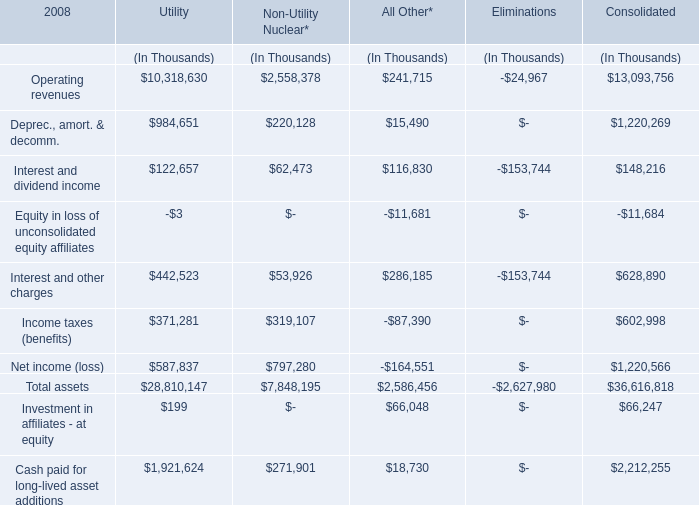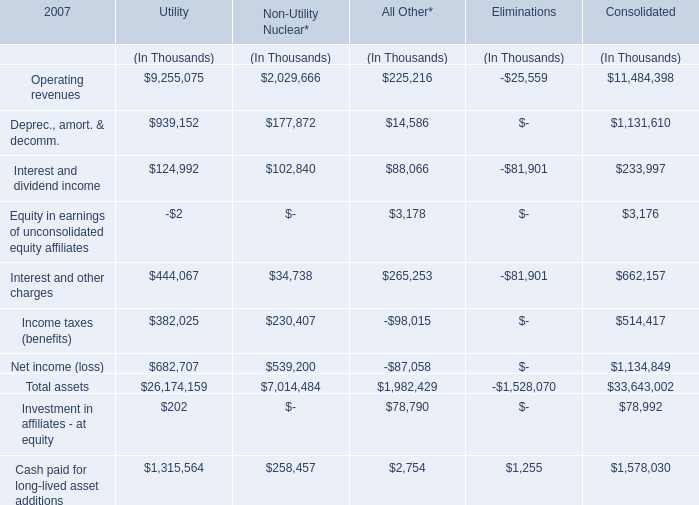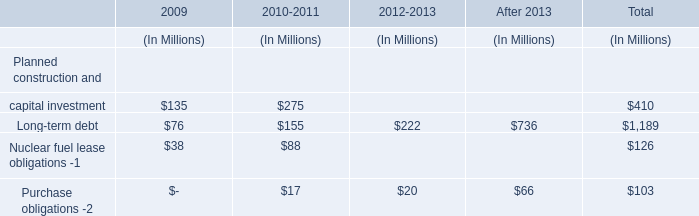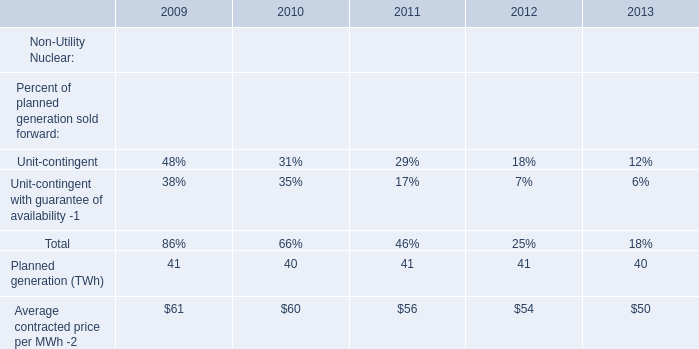What's the total value of all Operating revenues that are in the range of 0 and 10000000 thousand in 2007? (in thousand) 
Computations: ((9255075 + 2029666) + 225216)
Answer: 11509957.0. 